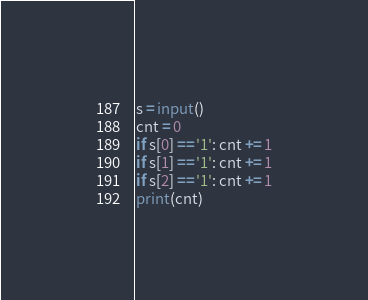Convert code to text. <code><loc_0><loc_0><loc_500><loc_500><_Python_>s = input()
cnt = 0
if s[0] == '1': cnt += 1
if s[1] == '1': cnt += 1
if s[2] == '1': cnt += 1
print(cnt)</code> 